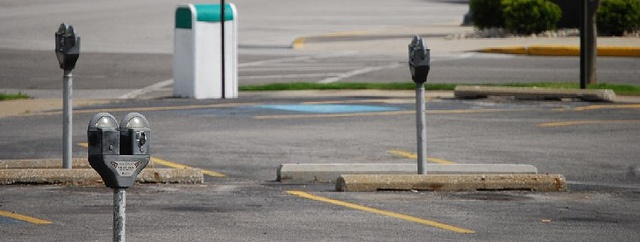Describe the objects in this image and their specific colors. I can see parking meter in gray, black, and darkgray tones, parking meter in gray, black, and darkgray tones, and parking meter in gray, black, and darkgray tones in this image. 